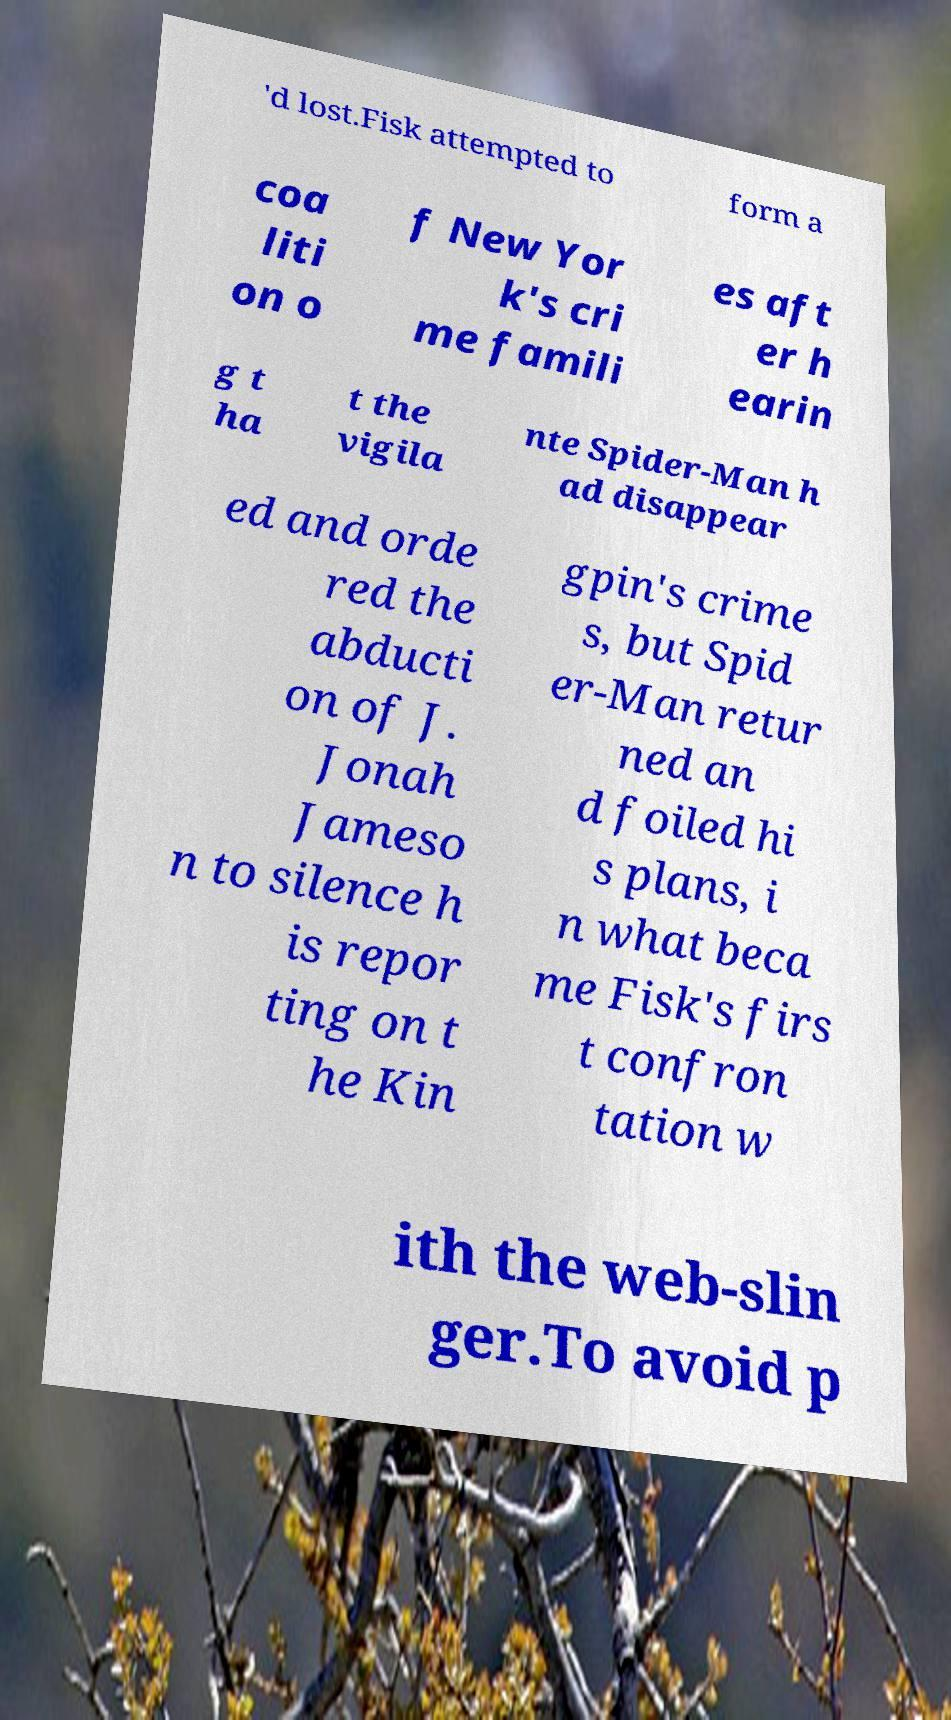There's text embedded in this image that I need extracted. Can you transcribe it verbatim? 'd lost.Fisk attempted to form a coa liti on o f New Yor k's cri me famili es aft er h earin g t ha t the vigila nte Spider-Man h ad disappear ed and orde red the abducti on of J. Jonah Jameso n to silence h is repor ting on t he Kin gpin's crime s, but Spid er-Man retur ned an d foiled hi s plans, i n what beca me Fisk's firs t confron tation w ith the web-slin ger.To avoid p 